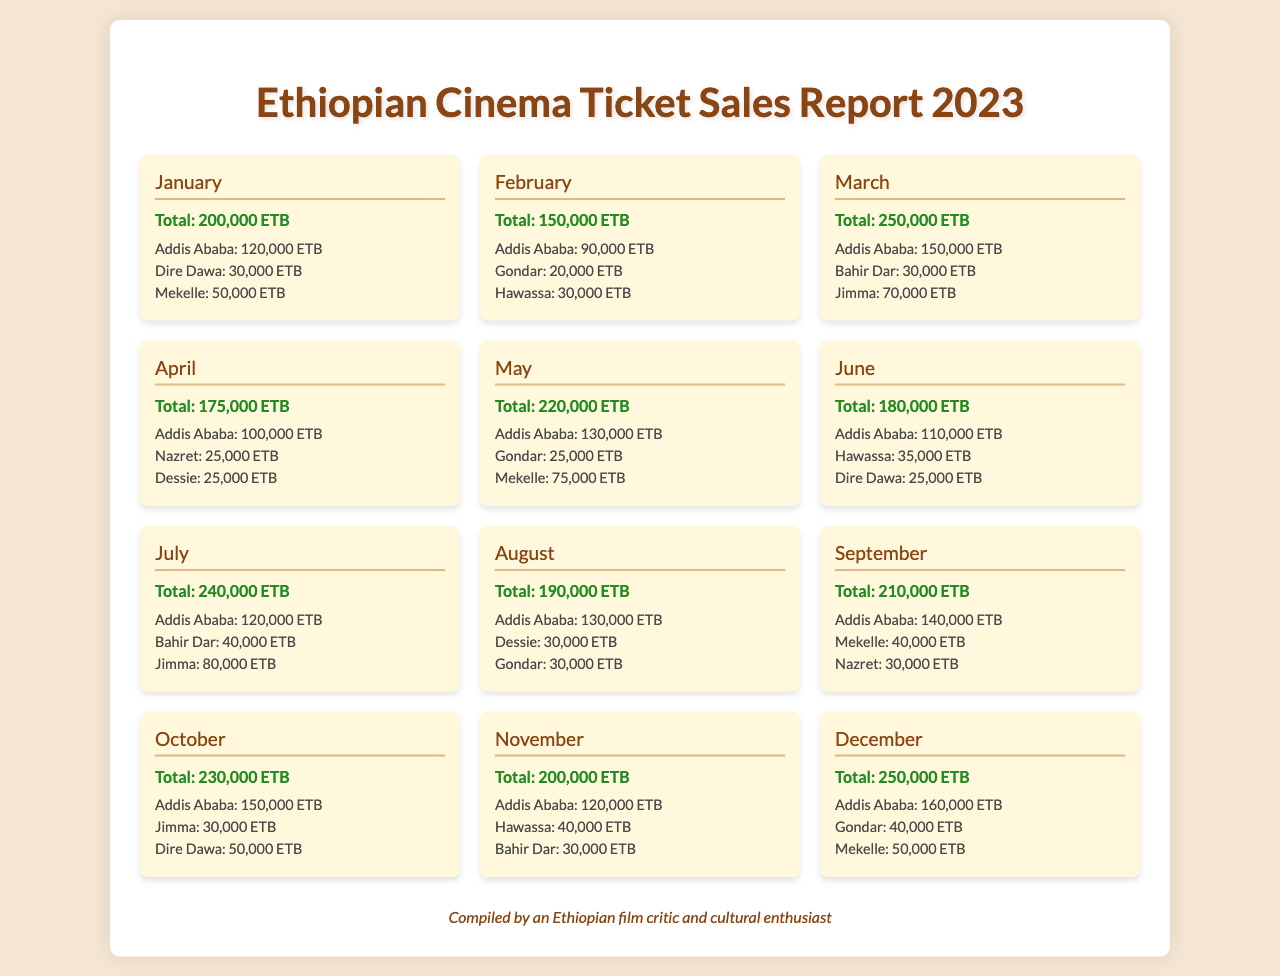What was the total revenue in October? The total revenue for October is listed in the document under that month's section.
Answer: 230,000 ETB Which month had the highest revenue? The document shows the total revenue for each month, and December's revenue is compared to others.
Answer: December How much did Addis Ababa generate in July? The revenue from Addis Ababa for July is specified in the respective month’s section.
Answer: 120,000 ETB What is the total revenue for February? February's total revenue is stated directly in the document under that month's section.
Answer: 150,000 ETB Which location had revenue of 40,000 ETB in November? The revenue for specific locations in November is provided in that month’s section.
Answer: Hawassa In which month did revenue first exceed 200,000 ETB? By examining the total revenues month by month, we find the first month with revenue above 200,000 ETB.
Answer: March What was the total revenue across all months? The total revenue can be calculated by summing up the totals from all months listed in the document.
Answer: 2,565,000 ETB Which month’s revenue decreased compared to the previous month? The revenue amounts are compared month to month, identifying where a decrease occurs.
Answer: February What is the lowest revenue month? The lowest total revenue can be identified by comparing all monthly revenues in the document.
Answer: February 